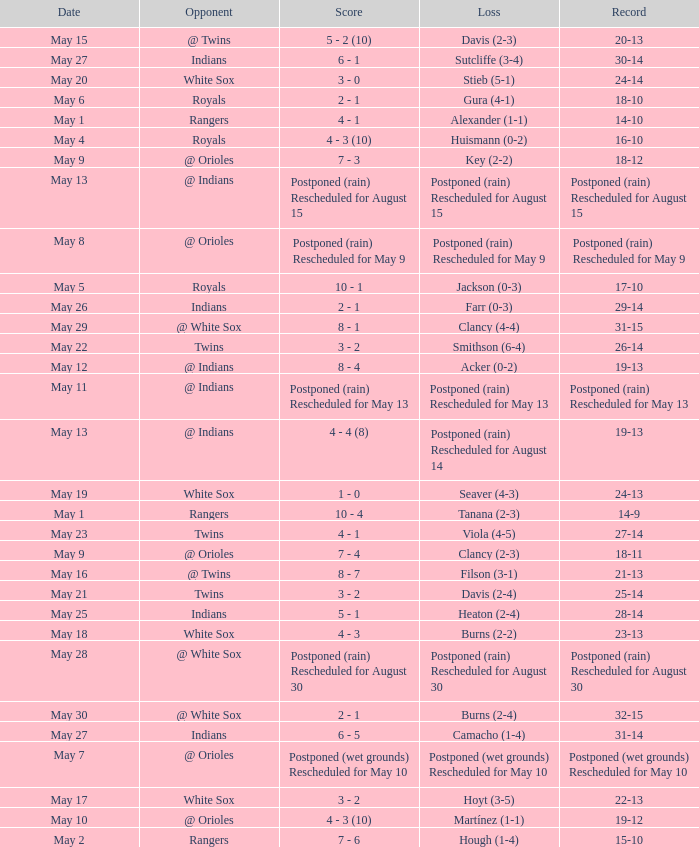What was date of the game when the record was 31-15? May 29. 